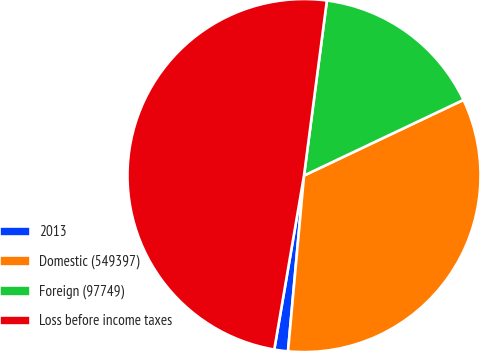Convert chart to OTSL. <chart><loc_0><loc_0><loc_500><loc_500><pie_chart><fcel>2013<fcel>Domestic (549397)<fcel>Foreign (97749)<fcel>Loss before income taxes<nl><fcel>1.25%<fcel>33.49%<fcel>15.88%<fcel>49.37%<nl></chart> 